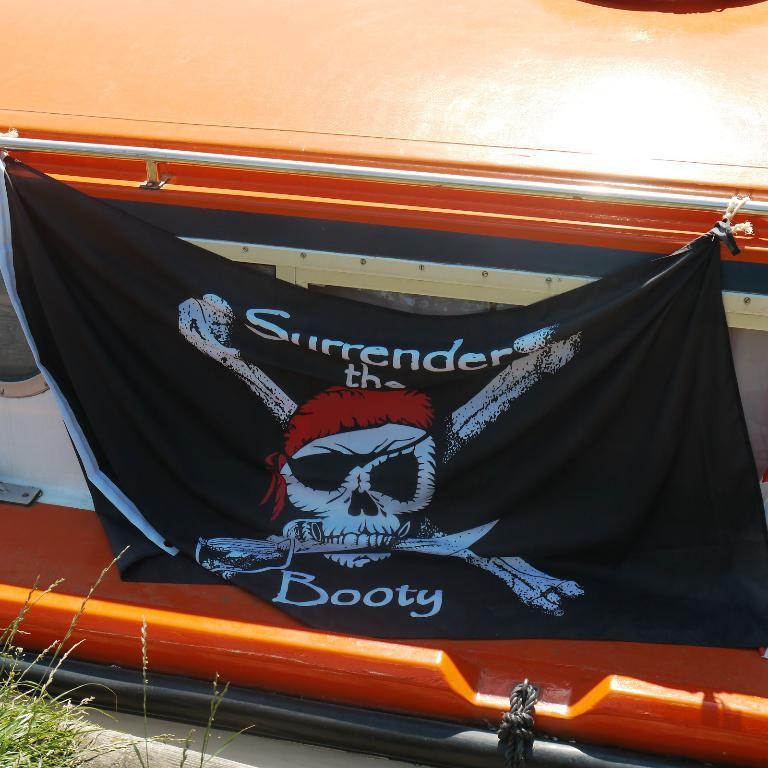What is the main subject of the image? There is a boat in the image. What is attached to the boat? A black flag is tied to the boat. What is depicted on the black flag? There is a skeleton on the black flag. What else can be seen in the image? There is a rope visible in the image. What type of vegetation is present in the image? There is grass in the image. How much honey is being produced by the bees in the image? There are no bees or honey present in the image; it features a boat with a black flag and a skeleton. What type of power source is being used by the boat in the image? The image does not provide information about the boat's power source. 